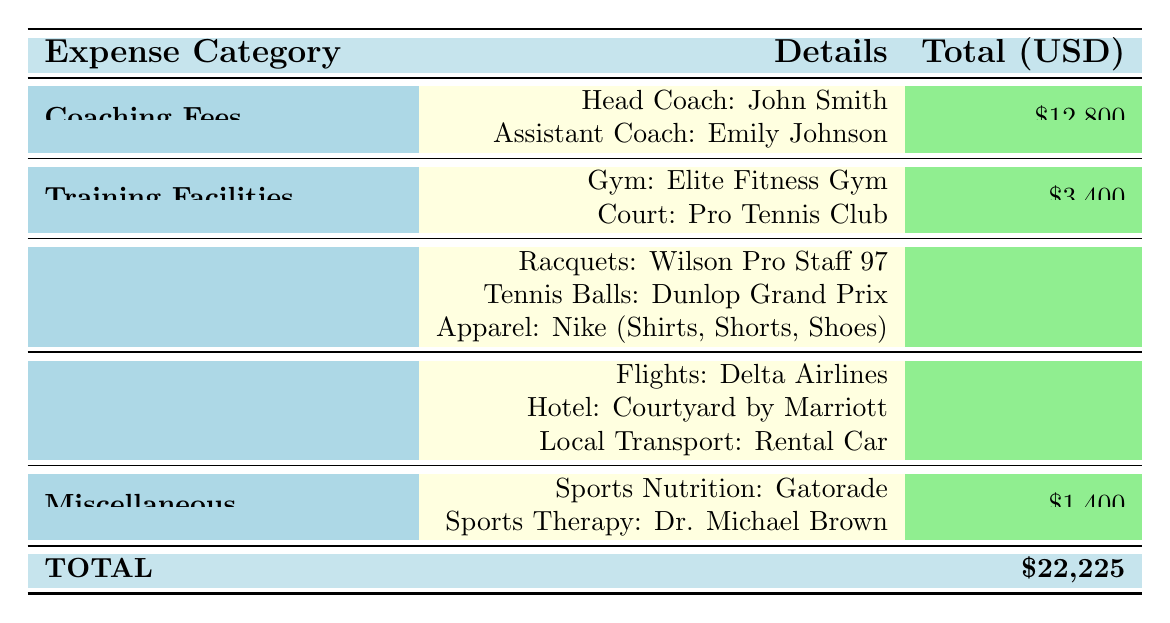What is the total cost for the coaching fees? The coaching fees are divided between the head coach and the assistant coach. The total cost from the table shows head coach fees as 9600 USD and assistant coach fees as 3200 USD. Adding these together gives 9600 + 3200 = 12800 USD.
Answer: 12800 USD What is the total amount spent on training facilities? The table shows the total cost of training facilities including gym membership for 200 USD and court rental for 3200 USD. Adding these together, 200 + 3200 equals 3400 USD.
Answer: 3400 USD How much was spent on travel and accommodation combined? According to the table, the total cost for flights is 600 USD, hotel is 2100 USD, and local transportation is 560 USD. Adding these values together gives 600 + 2100 + 560 = 3260 USD.
Answer: 3260 USD Is the total spent on equipment more than the total spent on coaching fees? The total cost for equipment is 1365 USD as per the table, and the total cost for coaching fees is 12800 USD. Since 1365 is less than 12800, the answer is no.
Answer: No How much did you spend on apparel specifically? The table breaks down the apparel costs: shirts cost 200 USD, shorts cost 175 USD, and shoes cost 240 USD. Adding these together: 200 + 175 + 240 equals 615 USD.
Answer: 615 USD What is the combined total of all expenses listed in the table? The total expenses are listed and broken down into categories. Adding these together gives: coaching 12800 + training facilities 3400 + equipment 1365 + travel and accommodation 3260 + miscellaneous 1400. Thus, 12800 + 3400 + 1365 + 3260 + 1400 equals 22225 USD.
Answer: 22225 USD Did you spend more on sports therapy than on sports nutrition? The table shows sports therapy at 1200 USD and sports nutrition at 200 USD. Since 1200 is greater than 200, the answer is yes.
Answer: Yes What was the total cost for equipment minus the cost of coaching fees? From the table, the total equipment cost is 1365 USD and coaching fees total 12800 USD. Subtracting these, 1365 from 12800 gives 11435 USD.
Answer: 11435 USD How many sessions did you have with the sports therapist? The data indicates there were 8 sessions with the therapist.
Answer: 8 sessions 